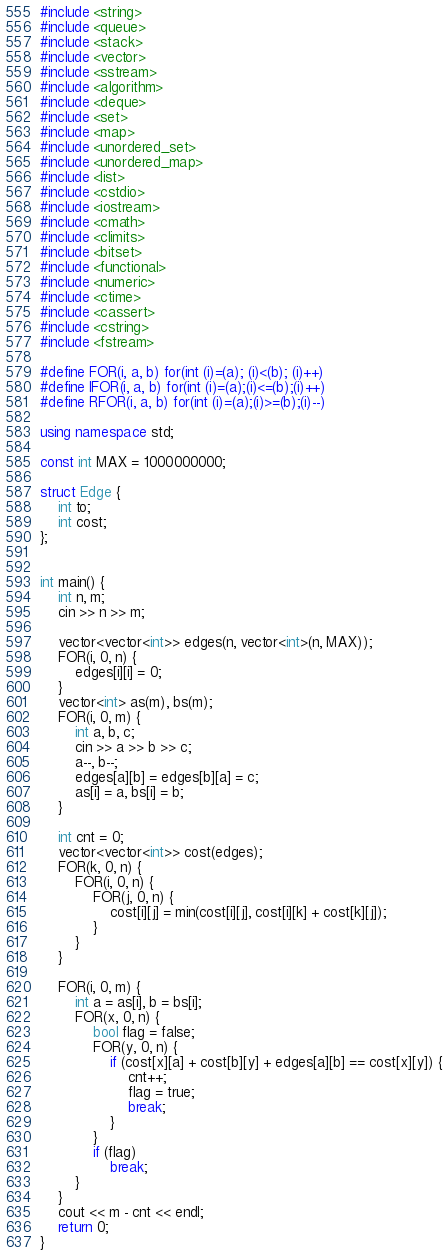Convert code to text. <code><loc_0><loc_0><loc_500><loc_500><_C++_>#include <string>
#include <queue>
#include <stack>
#include <vector>
#include <sstream>
#include <algorithm>
#include <deque>
#include <set>
#include <map>
#include <unordered_set>
#include <unordered_map>
#include <list>
#include <cstdio>
#include <iostream>
#include <cmath>
#include <climits>
#include <bitset>
#include <functional>
#include <numeric>
#include <ctime>
#include <cassert>
#include <cstring>
#include <fstream>

#define FOR(i, a, b) for(int (i)=(a); (i)<(b); (i)++)
#define IFOR(i, a, b) for(int (i)=(a);(i)<=(b);(i)++)
#define RFOR(i, a, b) for(int (i)=(a);(i)>=(b);(i)--)

using namespace std;

const int MAX = 1000000000;

struct Edge {
	int to;
	int cost;
};


int main() {
	int n, m;
	cin >> n >> m;

	vector<vector<int>> edges(n, vector<int>(n, MAX));
	FOR(i, 0, n) {
		edges[i][i] = 0;
	}
	vector<int> as(m), bs(m);
	FOR(i, 0, m) {
		int a, b, c;
		cin >> a >> b >> c;
		a--, b--;
		edges[a][b] = edges[b][a] = c;
		as[i] = a, bs[i] = b;
	}

	int cnt = 0;
	vector<vector<int>> cost(edges);
	FOR(k, 0, n) {
		FOR(i, 0, n) {
			FOR(j, 0, n) {
				cost[i][j] = min(cost[i][j], cost[i][k] + cost[k][j]);
			}
		}
	}

	FOR(i, 0, m) {
		int a = as[i], b = bs[i];
		FOR(x, 0, n) {
			bool flag = false;
			FOR(y, 0, n) {
				if (cost[x][a] + cost[b][y] + edges[a][b] == cost[x][y]) {
					cnt++;
					flag = true;
					break;
				}
			}
			if (flag)
				break;
		}
	}
	cout << m - cnt << endl;
	return 0;
}</code> 